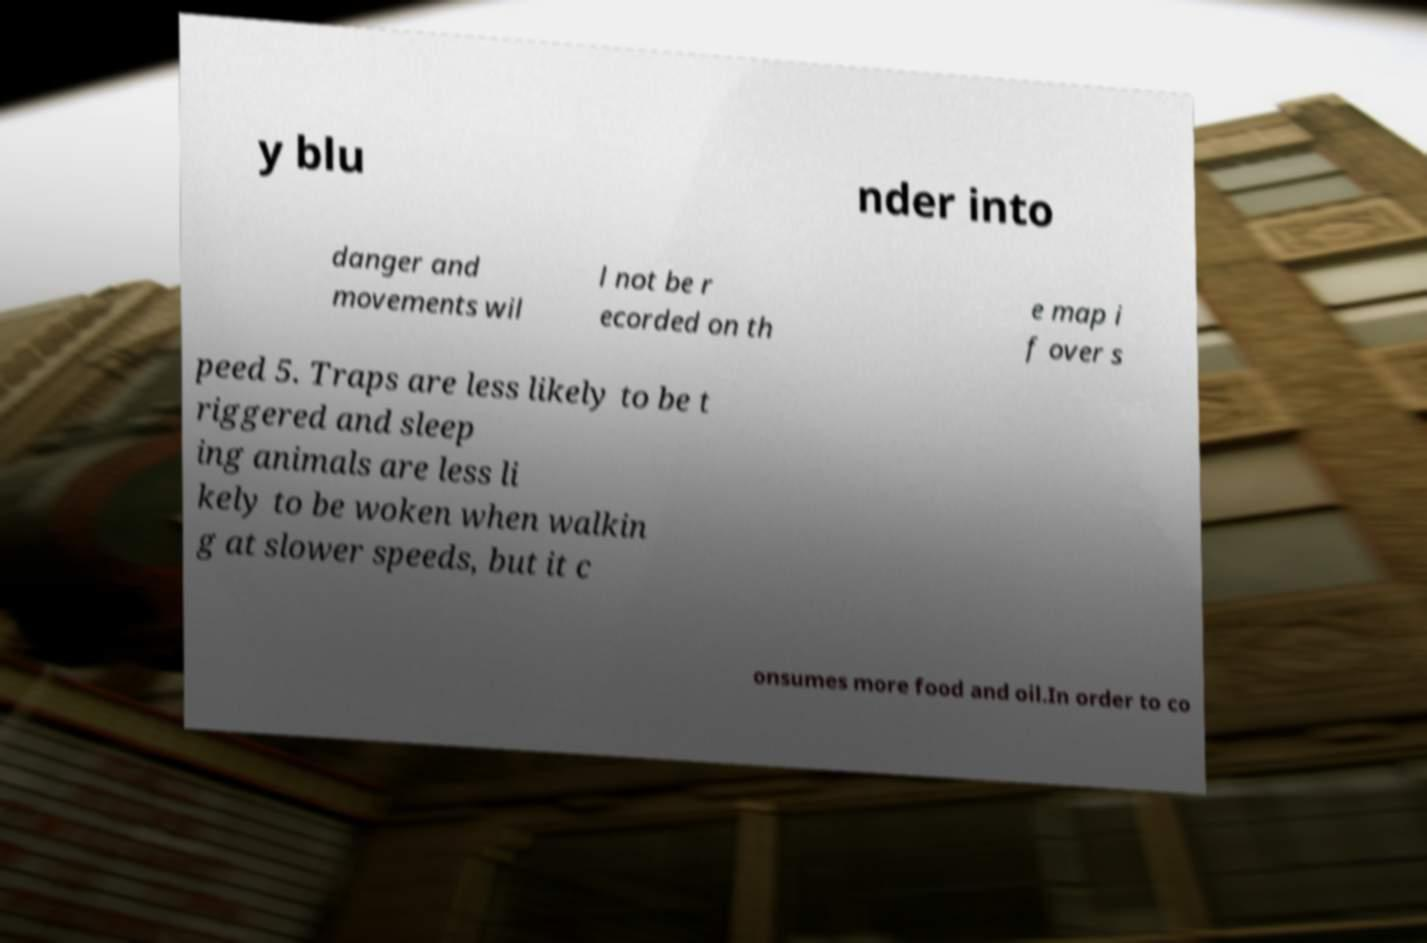For documentation purposes, I need the text within this image transcribed. Could you provide that? y blu nder into danger and movements wil l not be r ecorded on th e map i f over s peed 5. Traps are less likely to be t riggered and sleep ing animals are less li kely to be woken when walkin g at slower speeds, but it c onsumes more food and oil.In order to co 